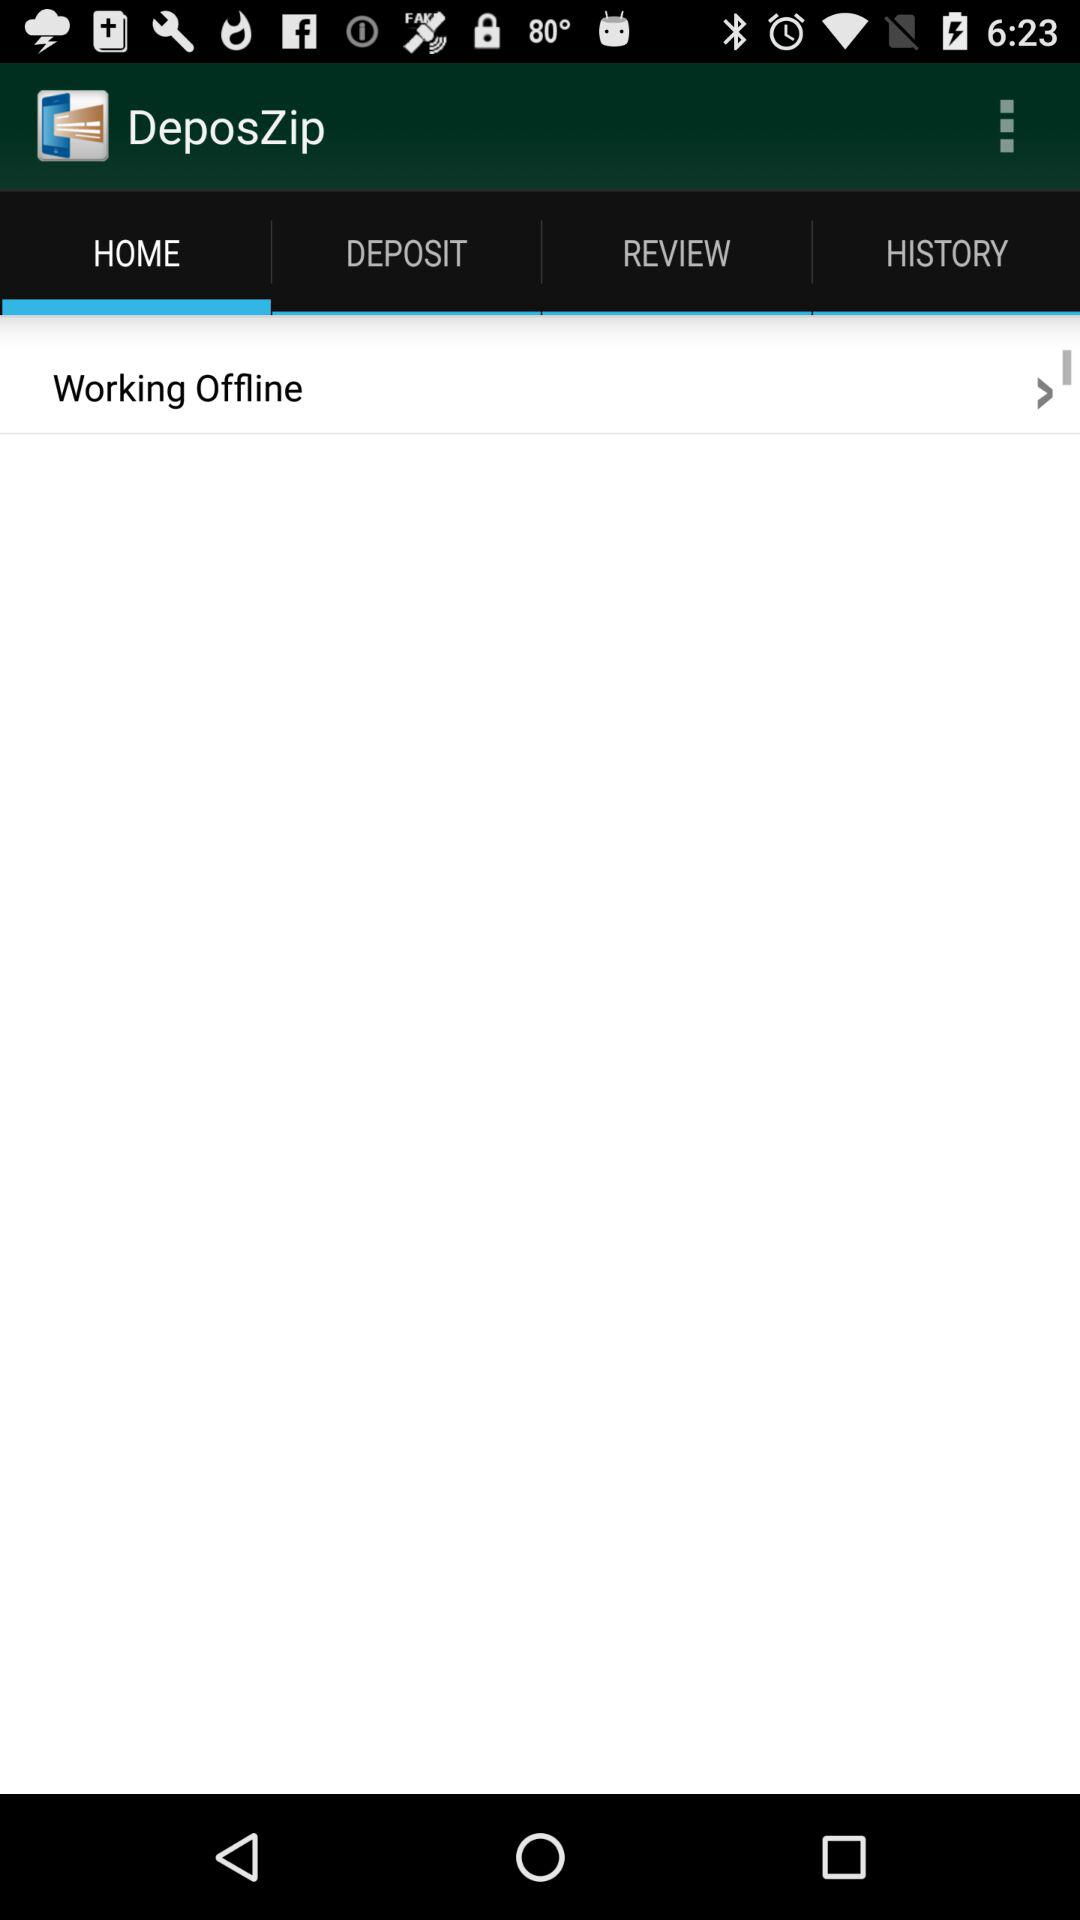Which tab has been selected? The selected tab is "HOME". 